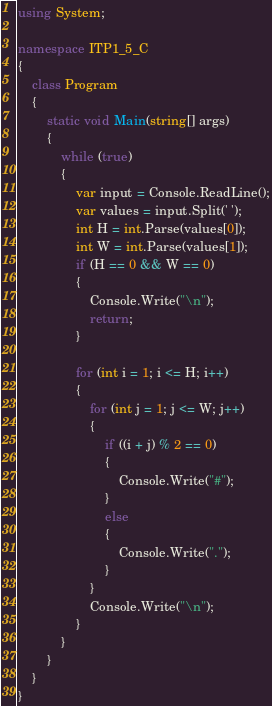Convert code to text. <code><loc_0><loc_0><loc_500><loc_500><_C#_>using System;

namespace ITP1_5_C
{
    class Program
    {
        static void Main(string[] args)
        {
            while (true)
            {
                var input = Console.ReadLine();
                var values = input.Split(' ');
                int H = int.Parse(values[0]);
                int W = int.Parse(values[1]);
                if (H == 0 && W == 0) 
                {
                    Console.Write("\n");
                    return; 
                }

                for (int i = 1; i <= H; i++)
                {
                    for (int j = 1; j <= W; j++)
                    {
                        if ((i + j) % 2 == 0)
                        {
                            Console.Write("#");
                        }
                        else
                        {
                            Console.Write(".");
                        }
                    }
                    Console.Write("\n");
                }
            }
        }
    }
}</code> 